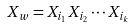Convert formula to latex. <formula><loc_0><loc_0><loc_500><loc_500>X _ { w } = X _ { i _ { 1 } } X _ { i _ { 2 } } \cdots X _ { i _ { k } }</formula> 